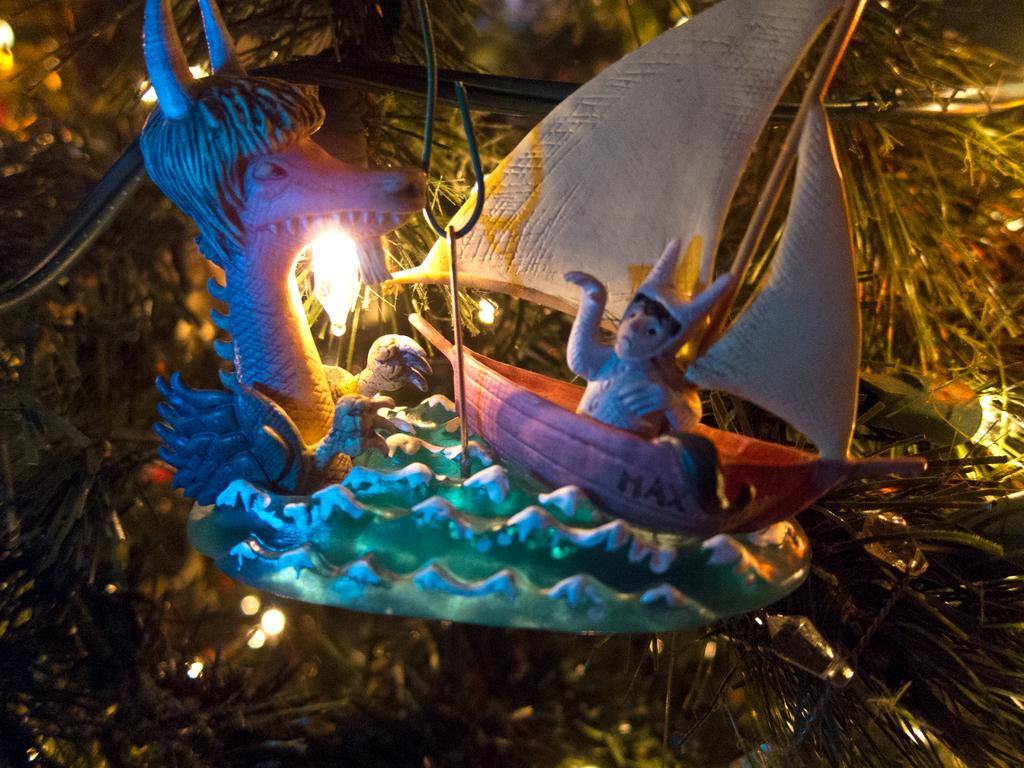What is the lighting condition in the image? The image was clicked in the dark. What objects can be seen in the image? There are toys visible in the image. Is there any source of light in the image? Yes, there is a light source in the image. What can be seen in the background of the image? There are leaves in the background of the image. What type of alarm is going off in the image? There is no alarm present in the image. What is the pump used for in the image? There is no pump present in the image. 